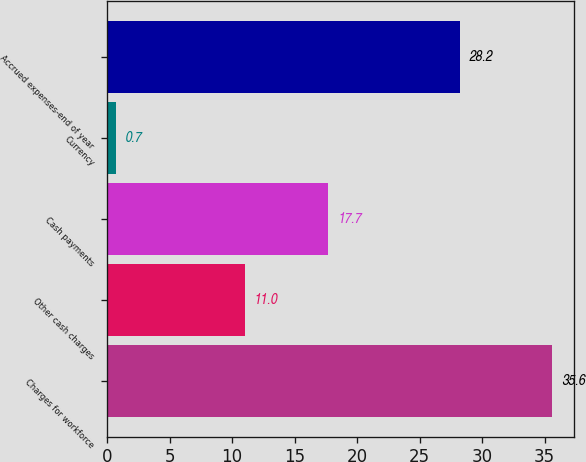Convert chart. <chart><loc_0><loc_0><loc_500><loc_500><bar_chart><fcel>Charges for workforce<fcel>Other cash charges<fcel>Cash payments<fcel>Currency<fcel>Accrued expenses-end of year<nl><fcel>35.6<fcel>11<fcel>17.7<fcel>0.7<fcel>28.2<nl></chart> 